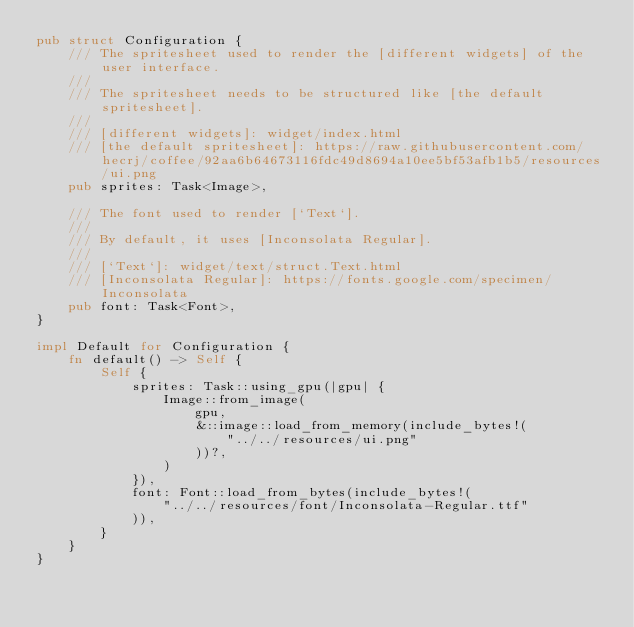Convert code to text. <code><loc_0><loc_0><loc_500><loc_500><_Rust_>pub struct Configuration {
    /// The spritesheet used to render the [different widgets] of the user interface.
    ///
    /// The spritesheet needs to be structured like [the default spritesheet].
    ///
    /// [different widgets]: widget/index.html
    /// [the default spritesheet]: https://raw.githubusercontent.com/hecrj/coffee/92aa6b64673116fdc49d8694a10ee5bf53afb1b5/resources/ui.png
    pub sprites: Task<Image>,

    /// The font used to render [`Text`].
    ///
    /// By default, it uses [Inconsolata Regular].
    ///
    /// [`Text`]: widget/text/struct.Text.html
    /// [Inconsolata Regular]: https://fonts.google.com/specimen/Inconsolata
    pub font: Task<Font>,
}

impl Default for Configuration {
    fn default() -> Self {
        Self {
            sprites: Task::using_gpu(|gpu| {
                Image::from_image(
                    gpu,
                    &::image::load_from_memory(include_bytes!(
                        "../../resources/ui.png"
                    ))?,
                )
            }),
            font: Font::load_from_bytes(include_bytes!(
                "../../resources/font/Inconsolata-Regular.ttf"
            )),
        }
    }
}
</code> 